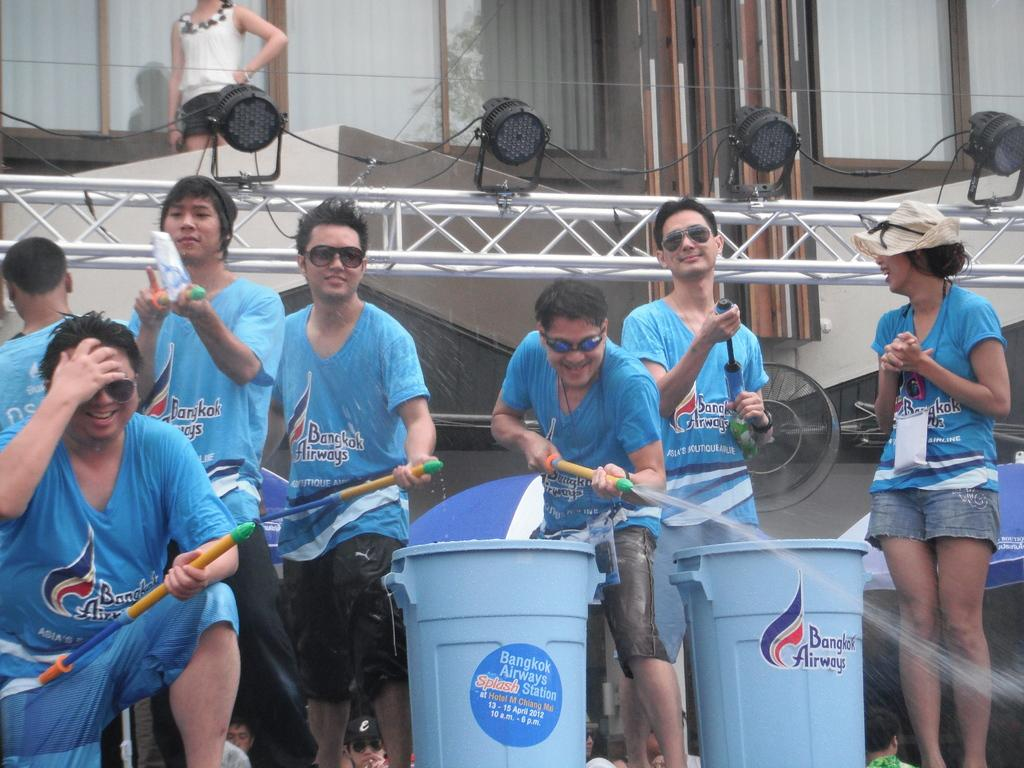<image>
Create a compact narrative representing the image presented. A garbage pail has a logo for Bangkok airlines on it. 